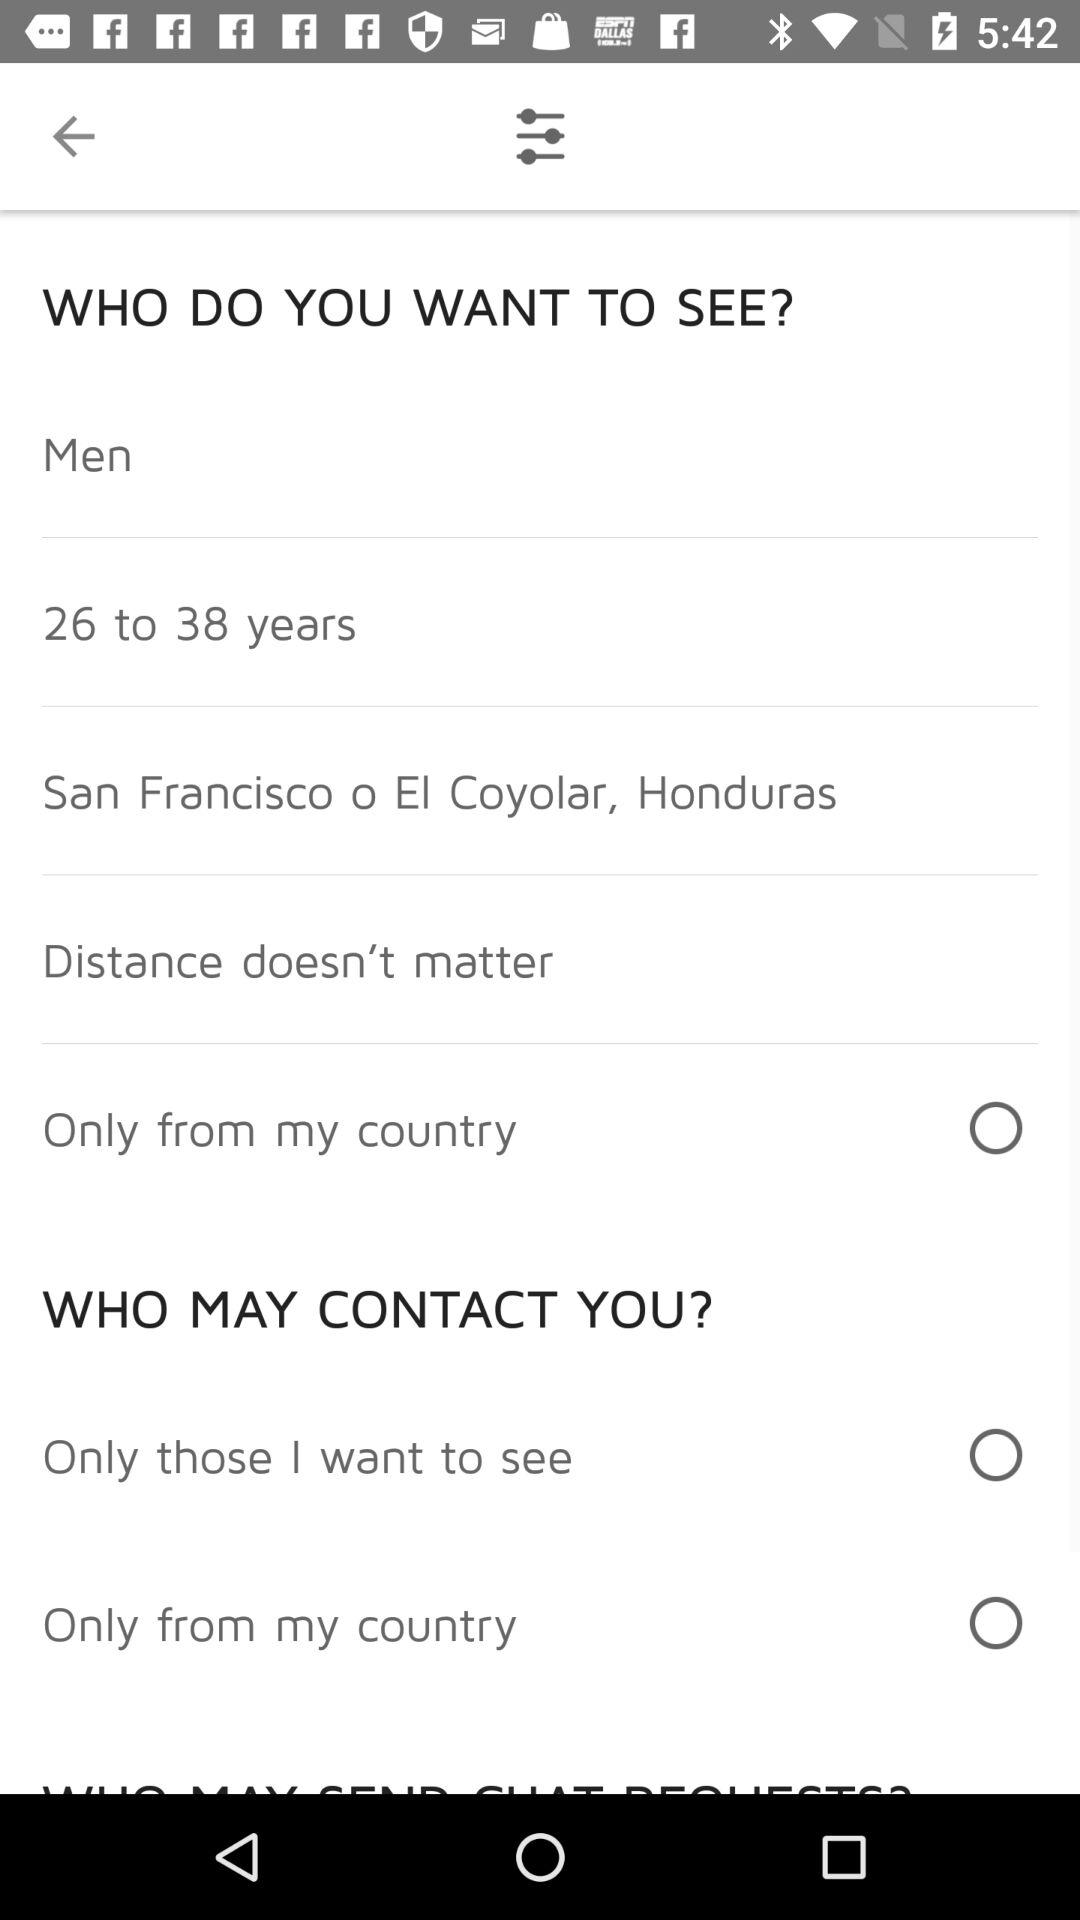What is the location? Th location is San Francisco o EI Coyolar, Honduras. 